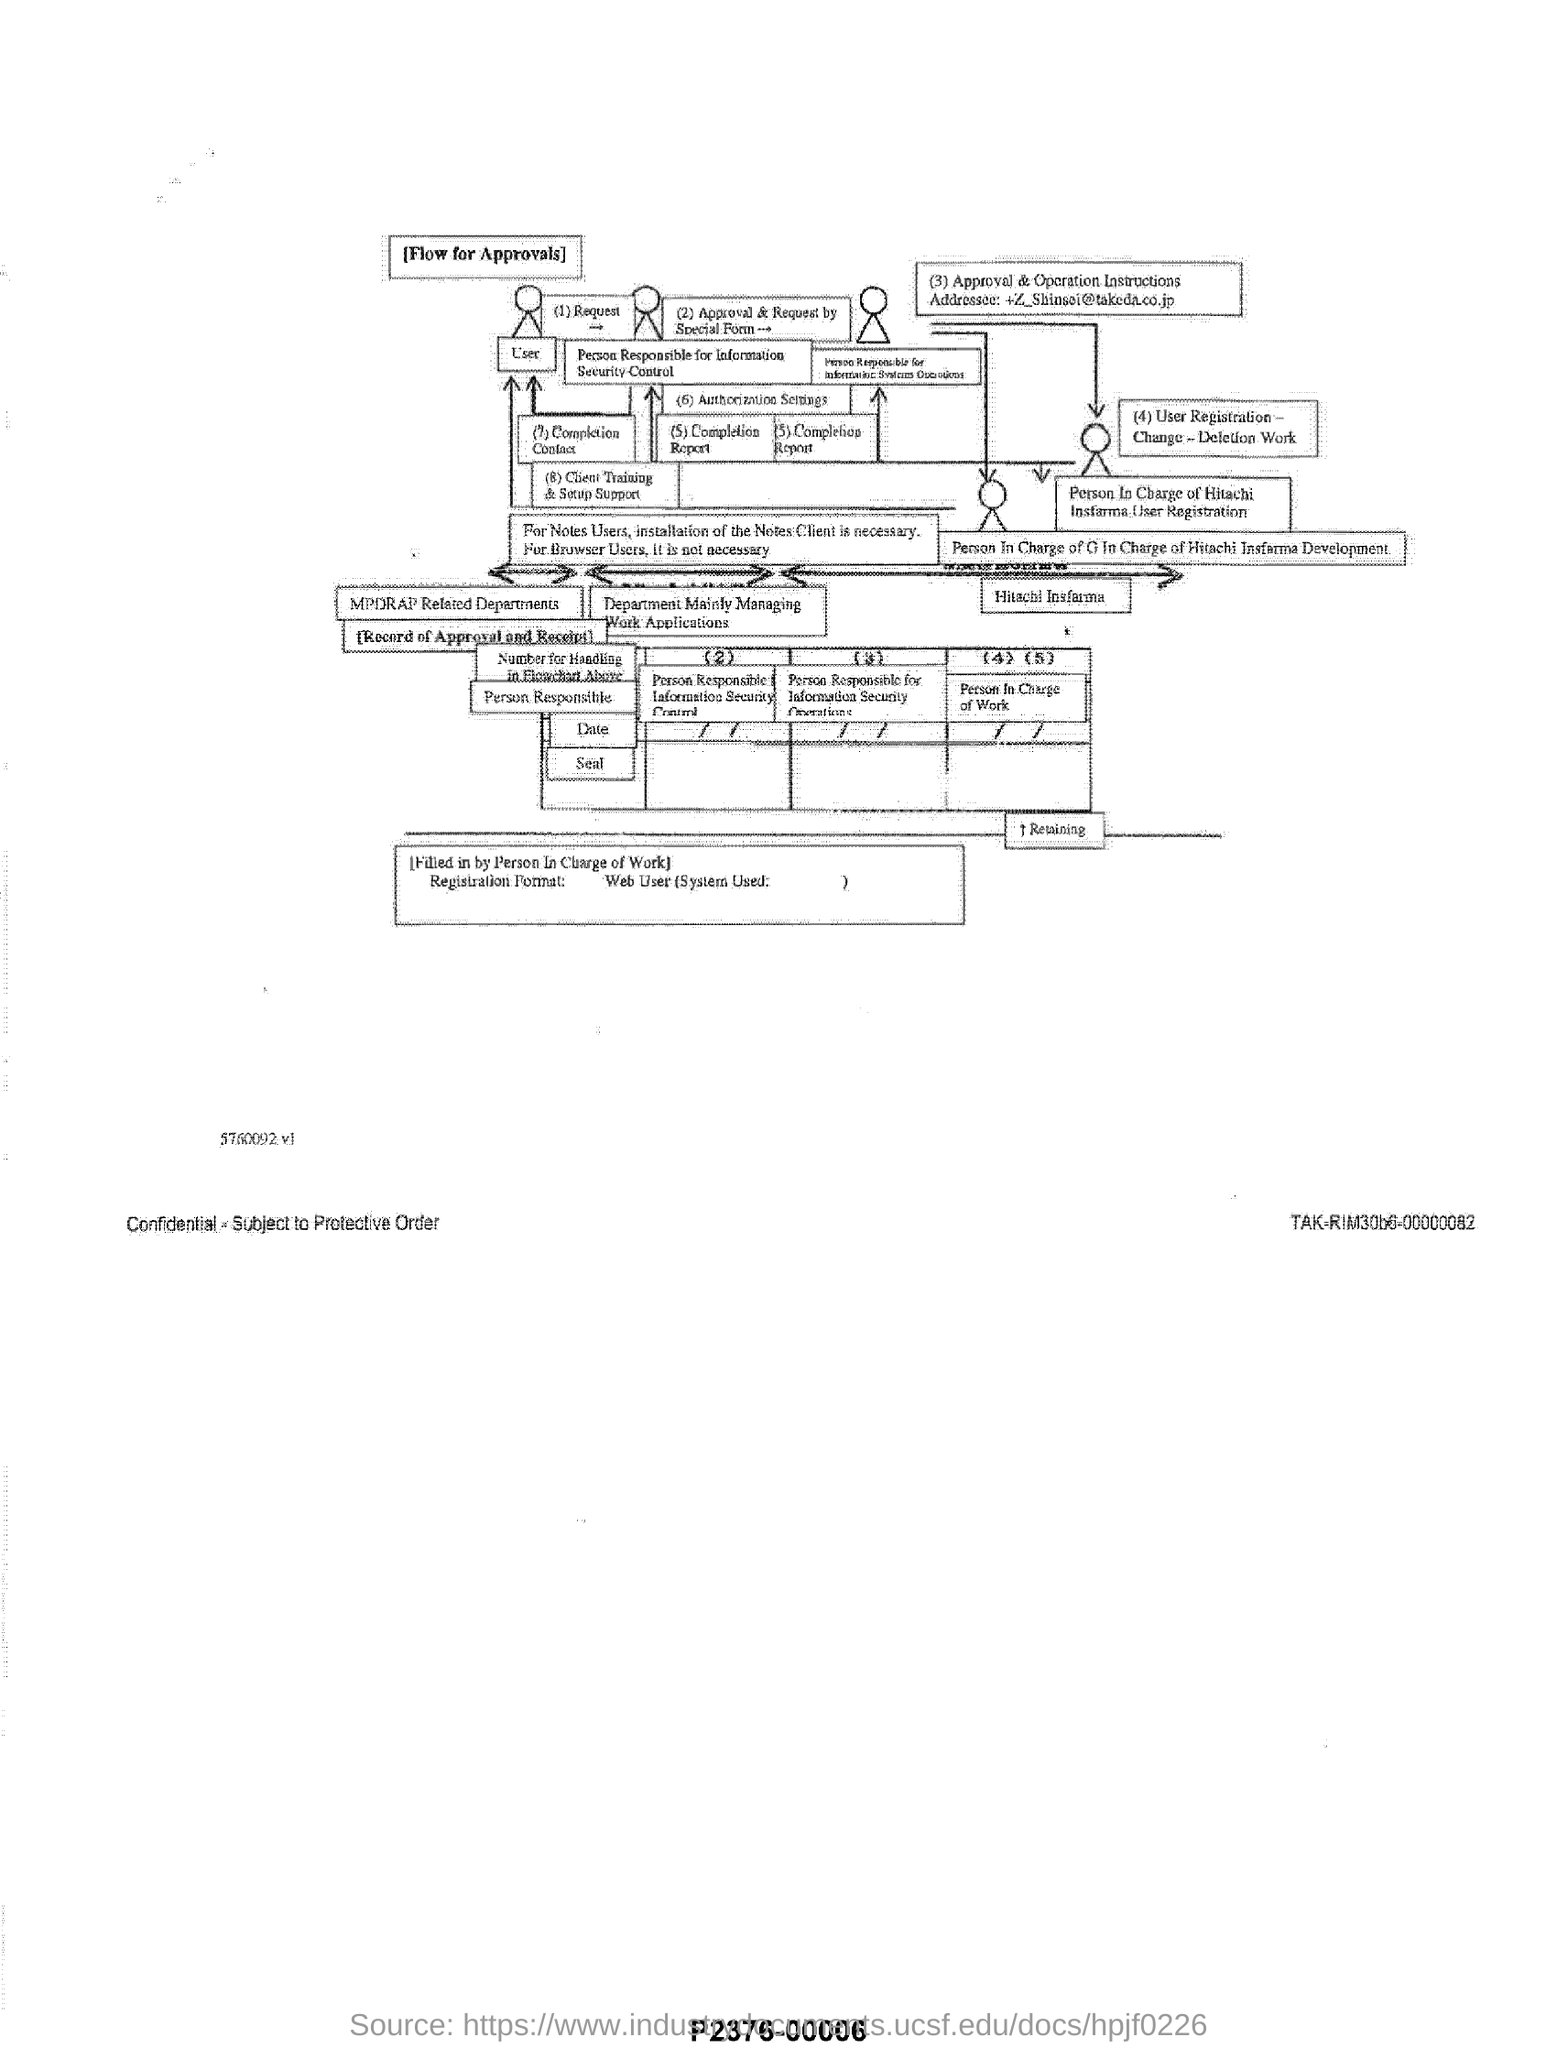Indicate a few pertinent items in this graphic. The flowchart is about a process for approvals. 